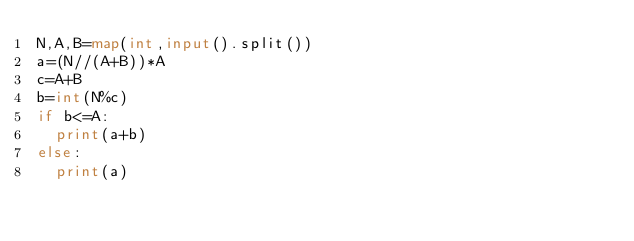Convert code to text. <code><loc_0><loc_0><loc_500><loc_500><_Python_>N,A,B=map(int,input().split())
a=(N//(A+B))*A
c=A+B
b=int(N%c)
if b<=A:
  print(a+b)
else:
  print(a)

</code> 